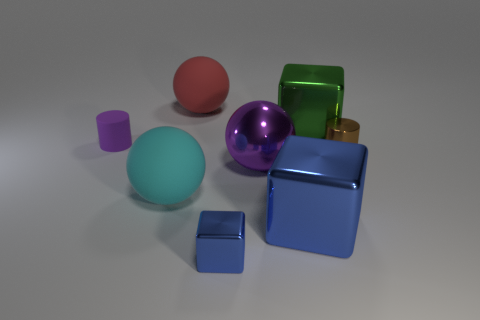Add 2 big cyan things. How many objects exist? 10 Subtract all blocks. How many objects are left? 5 Add 2 big red metal things. How many big red metal things exist? 2 Subtract 1 purple cylinders. How many objects are left? 7 Subtract all tiny shiny things. Subtract all cyan balls. How many objects are left? 5 Add 4 purple metal spheres. How many purple metal spheres are left? 5 